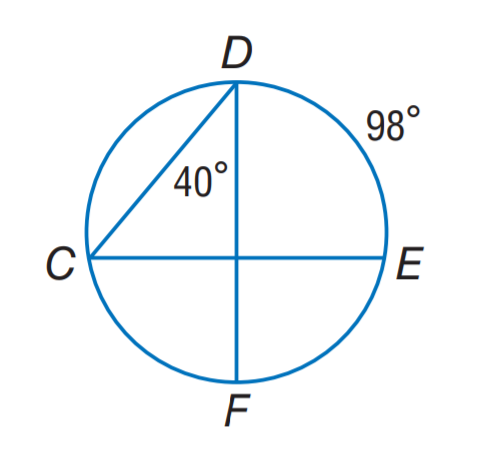Answer the mathemtical geometry problem and directly provide the correct option letter.
Question: Find m \angle C.
Choices: A: 40 B: 49 C: 80 D: 98 B 